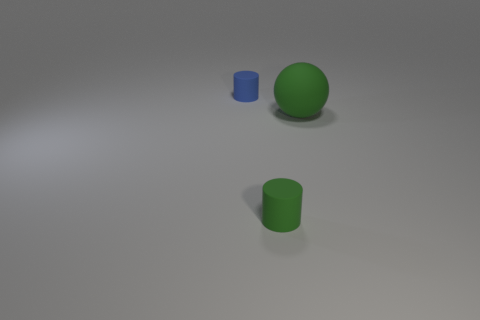Add 2 small brown metallic balls. How many objects exist? 5 Subtract all spheres. How many objects are left? 2 Subtract all small gray objects. Subtract all big things. How many objects are left? 2 Add 1 small cylinders. How many small cylinders are left? 3 Add 2 tiny matte things. How many tiny matte things exist? 4 Subtract 0 blue cubes. How many objects are left? 3 